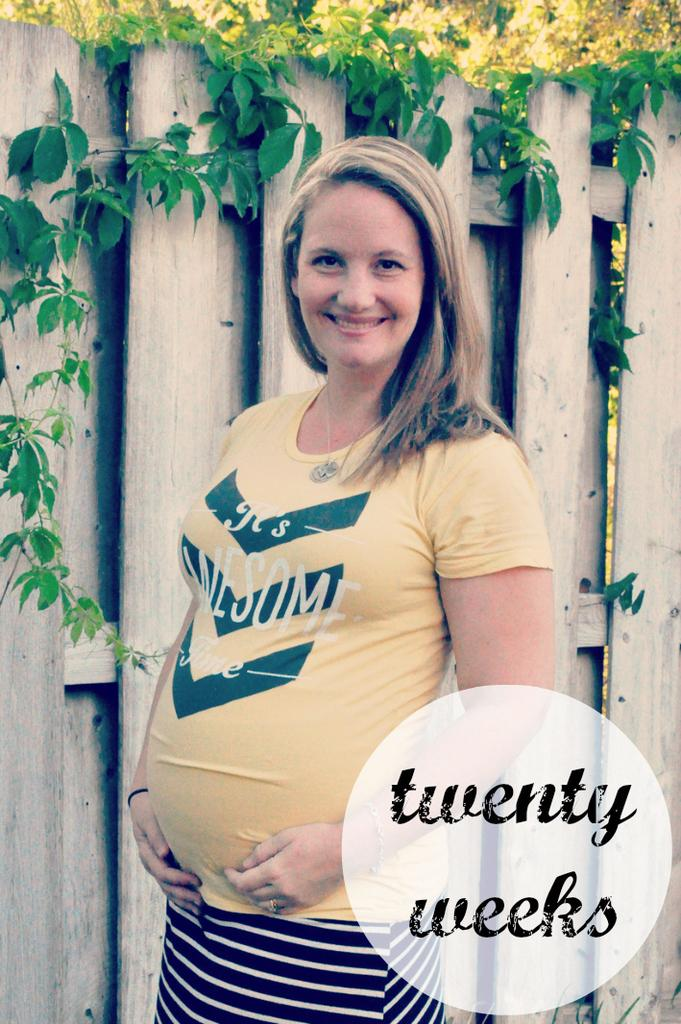<image>
Present a compact description of the photo's key features. A pregnant lady is telling others in this picture that she is 20 weeks gone. 